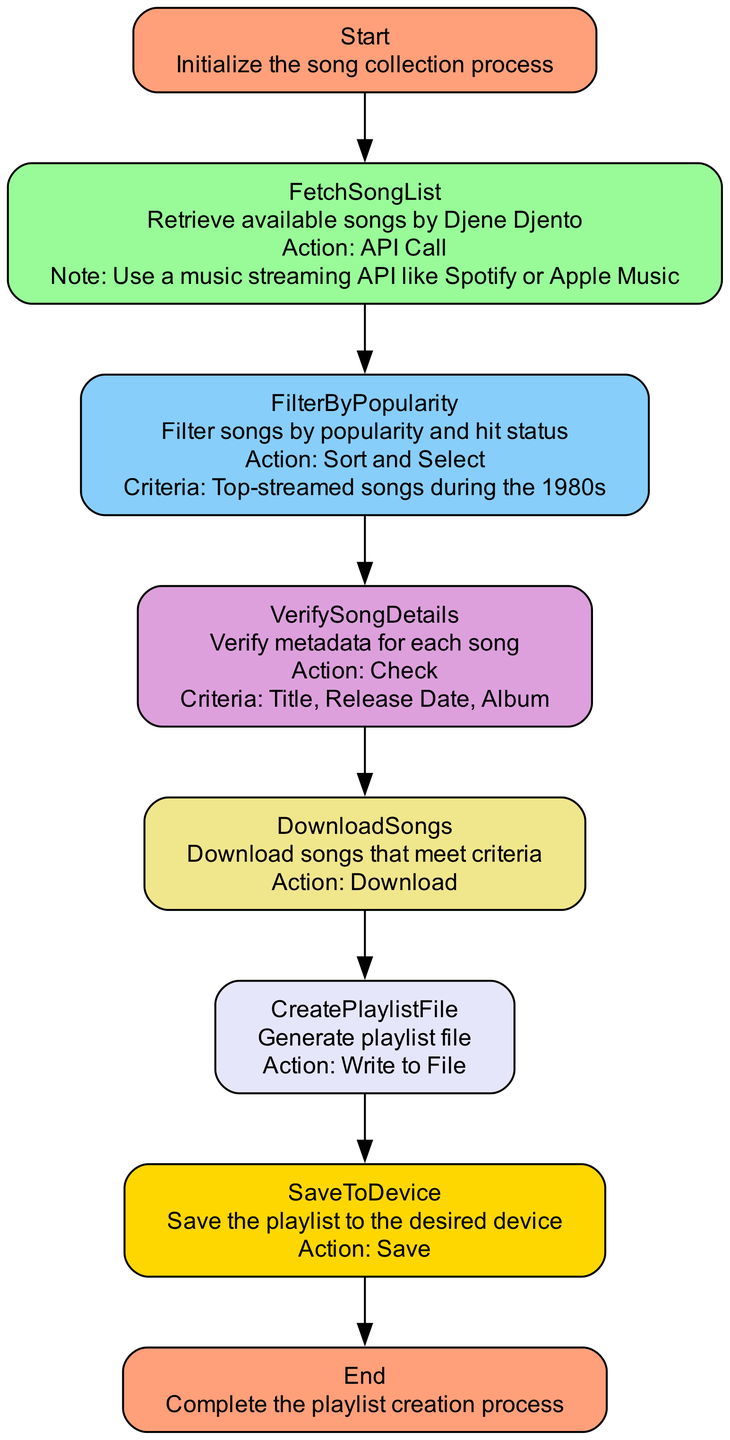What is the first step in the diagram? The diagram begins with the step labeled "Start," which initializes the song collection process. This can be determined as it is the first node listed in the flowchart.
Answer: Start How many total steps are in the process to create the playlist? By counting each step listed in the diagram, there are a total of eight steps indicated, ranging from "Start" to "End."
Answer: Eight What is the action taken in the step "FetchSongList"? The action specified for the "FetchSongList" step is "API Call," indicating that this step involves retrieving data. This information can be directly derived from the corresponding node.
Answer: API Call Which songs are filtered in the "FilterByPopularity" step? The filter criteria outlined in this step specify "Top-streamed songs during the 1980s," meaning that only songs with high streaming numbers from that decade are selected. This is a key detail noted in that step of the diagram.
Answer: Top-streamed songs during the 1980s What types of storage can the playlist be saved to in the "SaveToDevice" step? The diagram indicates two target options for storage: "Local storage" and "Cloud storage." This information is explicitly listed under the actions in that step.
Answer: Local storage, Cloud storage What criteria are verified in the "VerifySongDetails" step? In this step, the criteria listed for verification include "Title," "Release Date," and "Album." This is outlined in the corresponding node, which specifies the attributes checked for each song.
Answer: Title, Release Date, Album What action is taken after filtering songs by popularity? Following the "FilterByPopularity" step, the next action is "VerifySongDetails," which entails checking the metadata for each song. This flow is evident as it connects directly to the next node in the sequence.
Answer: VerifySongDetails Which step generates the playlist file? The step responsible for generating the playlist file is "CreatePlaylistFile," as indicated in the flowchart. This step provides the action of writing the playlist data to a file format specified as M3U.
Answer: CreatePlaylistFile 